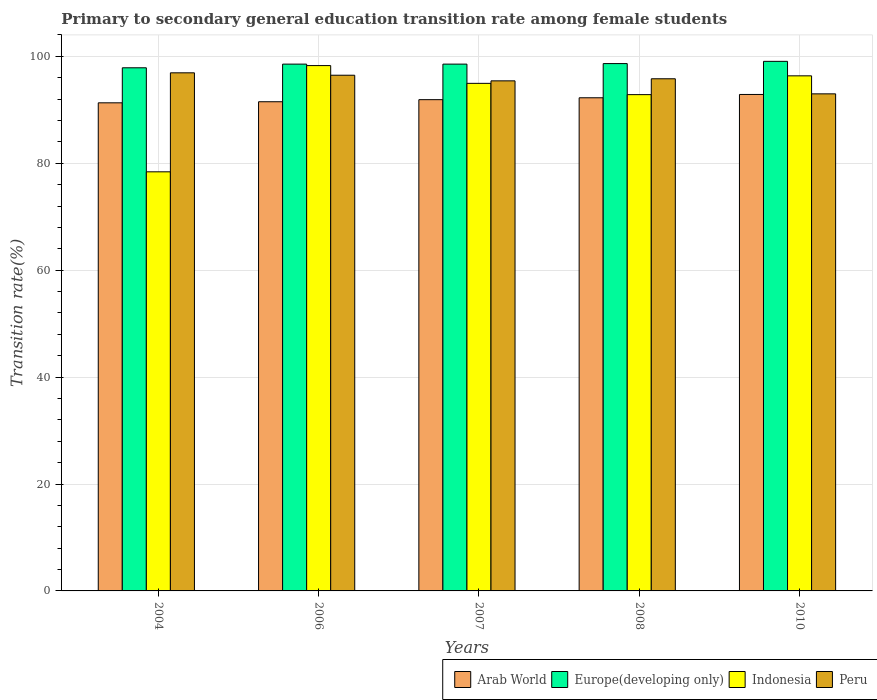How many different coloured bars are there?
Offer a terse response. 4. Are the number of bars per tick equal to the number of legend labels?
Keep it short and to the point. Yes. Are the number of bars on each tick of the X-axis equal?
Ensure brevity in your answer.  Yes. How many bars are there on the 2nd tick from the left?
Your answer should be very brief. 4. In how many cases, is the number of bars for a given year not equal to the number of legend labels?
Your response must be concise. 0. What is the transition rate in Europe(developing only) in 2010?
Your response must be concise. 99.07. Across all years, what is the maximum transition rate in Indonesia?
Your answer should be very brief. 98.28. Across all years, what is the minimum transition rate in Indonesia?
Make the answer very short. 78.4. In which year was the transition rate in Europe(developing only) minimum?
Make the answer very short. 2004. What is the total transition rate in Indonesia in the graph?
Give a very brief answer. 460.83. What is the difference between the transition rate in Peru in 2004 and that in 2006?
Make the answer very short. 0.45. What is the difference between the transition rate in Indonesia in 2010 and the transition rate in Europe(developing only) in 2004?
Your answer should be very brief. -1.5. What is the average transition rate in Arab World per year?
Your answer should be very brief. 91.97. In the year 2004, what is the difference between the transition rate in Europe(developing only) and transition rate in Peru?
Offer a very short reply. 0.94. In how many years, is the transition rate in Peru greater than 80 %?
Offer a very short reply. 5. What is the ratio of the transition rate in Arab World in 2004 to that in 2006?
Provide a short and direct response. 1. Is the transition rate in Europe(developing only) in 2007 less than that in 2010?
Offer a very short reply. Yes. What is the difference between the highest and the second highest transition rate in Arab World?
Provide a short and direct response. 0.62. What is the difference between the highest and the lowest transition rate in Europe(developing only)?
Offer a terse response. 1.2. Is it the case that in every year, the sum of the transition rate in Arab World and transition rate in Peru is greater than the sum of transition rate in Indonesia and transition rate in Europe(developing only)?
Your response must be concise. No. What does the 1st bar from the left in 2007 represents?
Your answer should be compact. Arab World. What does the 3rd bar from the right in 2006 represents?
Your answer should be compact. Europe(developing only). Is it the case that in every year, the sum of the transition rate in Indonesia and transition rate in Arab World is greater than the transition rate in Peru?
Make the answer very short. Yes. How many years are there in the graph?
Offer a terse response. 5. What is the difference between two consecutive major ticks on the Y-axis?
Keep it short and to the point. 20. Does the graph contain grids?
Offer a very short reply. Yes. How many legend labels are there?
Your answer should be very brief. 4. What is the title of the graph?
Provide a short and direct response. Primary to secondary general education transition rate among female students. What is the label or title of the X-axis?
Ensure brevity in your answer.  Years. What is the label or title of the Y-axis?
Offer a terse response. Transition rate(%). What is the Transition rate(%) in Arab World in 2004?
Offer a terse response. 91.31. What is the Transition rate(%) of Europe(developing only) in 2004?
Provide a short and direct response. 97.86. What is the Transition rate(%) in Indonesia in 2004?
Keep it short and to the point. 78.4. What is the Transition rate(%) of Peru in 2004?
Provide a short and direct response. 96.92. What is the Transition rate(%) in Arab World in 2006?
Your answer should be compact. 91.51. What is the Transition rate(%) in Europe(developing only) in 2006?
Offer a terse response. 98.55. What is the Transition rate(%) in Indonesia in 2006?
Make the answer very short. 98.28. What is the Transition rate(%) in Peru in 2006?
Provide a short and direct response. 96.47. What is the Transition rate(%) of Arab World in 2007?
Your response must be concise. 91.9. What is the Transition rate(%) of Europe(developing only) in 2007?
Give a very brief answer. 98.55. What is the Transition rate(%) of Indonesia in 2007?
Keep it short and to the point. 94.95. What is the Transition rate(%) in Peru in 2007?
Offer a very short reply. 95.42. What is the Transition rate(%) of Arab World in 2008?
Give a very brief answer. 92.25. What is the Transition rate(%) in Europe(developing only) in 2008?
Offer a very short reply. 98.65. What is the Transition rate(%) of Indonesia in 2008?
Provide a succinct answer. 92.84. What is the Transition rate(%) in Peru in 2008?
Keep it short and to the point. 95.81. What is the Transition rate(%) of Arab World in 2010?
Provide a short and direct response. 92.87. What is the Transition rate(%) in Europe(developing only) in 2010?
Your answer should be very brief. 99.07. What is the Transition rate(%) of Indonesia in 2010?
Your answer should be very brief. 96.36. What is the Transition rate(%) in Peru in 2010?
Offer a very short reply. 92.99. Across all years, what is the maximum Transition rate(%) in Arab World?
Your response must be concise. 92.87. Across all years, what is the maximum Transition rate(%) of Europe(developing only)?
Your answer should be compact. 99.07. Across all years, what is the maximum Transition rate(%) of Indonesia?
Ensure brevity in your answer.  98.28. Across all years, what is the maximum Transition rate(%) in Peru?
Ensure brevity in your answer.  96.92. Across all years, what is the minimum Transition rate(%) of Arab World?
Your answer should be very brief. 91.31. Across all years, what is the minimum Transition rate(%) of Europe(developing only)?
Your answer should be very brief. 97.86. Across all years, what is the minimum Transition rate(%) of Indonesia?
Give a very brief answer. 78.4. Across all years, what is the minimum Transition rate(%) of Peru?
Provide a succinct answer. 92.99. What is the total Transition rate(%) in Arab World in the graph?
Ensure brevity in your answer.  459.85. What is the total Transition rate(%) of Europe(developing only) in the graph?
Your answer should be compact. 492.68. What is the total Transition rate(%) in Indonesia in the graph?
Give a very brief answer. 460.83. What is the total Transition rate(%) in Peru in the graph?
Provide a short and direct response. 477.61. What is the difference between the Transition rate(%) in Arab World in 2004 and that in 2006?
Ensure brevity in your answer.  -0.2. What is the difference between the Transition rate(%) of Europe(developing only) in 2004 and that in 2006?
Your answer should be compact. -0.69. What is the difference between the Transition rate(%) in Indonesia in 2004 and that in 2006?
Offer a terse response. -19.87. What is the difference between the Transition rate(%) in Peru in 2004 and that in 2006?
Offer a very short reply. 0.45. What is the difference between the Transition rate(%) in Arab World in 2004 and that in 2007?
Your answer should be very brief. -0.59. What is the difference between the Transition rate(%) of Europe(developing only) in 2004 and that in 2007?
Your answer should be compact. -0.69. What is the difference between the Transition rate(%) of Indonesia in 2004 and that in 2007?
Your response must be concise. -16.55. What is the difference between the Transition rate(%) of Peru in 2004 and that in 2007?
Make the answer very short. 1.5. What is the difference between the Transition rate(%) of Arab World in 2004 and that in 2008?
Your answer should be very brief. -0.94. What is the difference between the Transition rate(%) of Europe(developing only) in 2004 and that in 2008?
Offer a terse response. -0.79. What is the difference between the Transition rate(%) of Indonesia in 2004 and that in 2008?
Give a very brief answer. -14.44. What is the difference between the Transition rate(%) in Peru in 2004 and that in 2008?
Provide a short and direct response. 1.11. What is the difference between the Transition rate(%) of Arab World in 2004 and that in 2010?
Keep it short and to the point. -1.56. What is the difference between the Transition rate(%) in Europe(developing only) in 2004 and that in 2010?
Offer a terse response. -1.2. What is the difference between the Transition rate(%) of Indonesia in 2004 and that in 2010?
Your response must be concise. -17.96. What is the difference between the Transition rate(%) in Peru in 2004 and that in 2010?
Provide a short and direct response. 3.93. What is the difference between the Transition rate(%) of Arab World in 2006 and that in 2007?
Your answer should be very brief. -0.39. What is the difference between the Transition rate(%) of Europe(developing only) in 2006 and that in 2007?
Your response must be concise. -0. What is the difference between the Transition rate(%) in Indonesia in 2006 and that in 2007?
Ensure brevity in your answer.  3.33. What is the difference between the Transition rate(%) of Peru in 2006 and that in 2007?
Provide a short and direct response. 1.05. What is the difference between the Transition rate(%) of Arab World in 2006 and that in 2008?
Offer a terse response. -0.74. What is the difference between the Transition rate(%) in Europe(developing only) in 2006 and that in 2008?
Give a very brief answer. -0.1. What is the difference between the Transition rate(%) in Indonesia in 2006 and that in 2008?
Provide a succinct answer. 5.43. What is the difference between the Transition rate(%) of Peru in 2006 and that in 2008?
Your answer should be very brief. 0.66. What is the difference between the Transition rate(%) of Arab World in 2006 and that in 2010?
Keep it short and to the point. -1.36. What is the difference between the Transition rate(%) in Europe(developing only) in 2006 and that in 2010?
Your answer should be very brief. -0.52. What is the difference between the Transition rate(%) in Indonesia in 2006 and that in 2010?
Ensure brevity in your answer.  1.92. What is the difference between the Transition rate(%) in Peru in 2006 and that in 2010?
Your answer should be compact. 3.48. What is the difference between the Transition rate(%) of Arab World in 2007 and that in 2008?
Make the answer very short. -0.35. What is the difference between the Transition rate(%) in Europe(developing only) in 2007 and that in 2008?
Provide a succinct answer. -0.1. What is the difference between the Transition rate(%) of Indonesia in 2007 and that in 2008?
Make the answer very short. 2.11. What is the difference between the Transition rate(%) of Peru in 2007 and that in 2008?
Keep it short and to the point. -0.39. What is the difference between the Transition rate(%) in Arab World in 2007 and that in 2010?
Your answer should be very brief. -0.97. What is the difference between the Transition rate(%) in Europe(developing only) in 2007 and that in 2010?
Make the answer very short. -0.52. What is the difference between the Transition rate(%) of Indonesia in 2007 and that in 2010?
Ensure brevity in your answer.  -1.41. What is the difference between the Transition rate(%) of Peru in 2007 and that in 2010?
Keep it short and to the point. 2.43. What is the difference between the Transition rate(%) in Arab World in 2008 and that in 2010?
Ensure brevity in your answer.  -0.62. What is the difference between the Transition rate(%) of Europe(developing only) in 2008 and that in 2010?
Keep it short and to the point. -0.42. What is the difference between the Transition rate(%) of Indonesia in 2008 and that in 2010?
Your answer should be very brief. -3.52. What is the difference between the Transition rate(%) in Peru in 2008 and that in 2010?
Make the answer very short. 2.82. What is the difference between the Transition rate(%) of Arab World in 2004 and the Transition rate(%) of Europe(developing only) in 2006?
Provide a short and direct response. -7.24. What is the difference between the Transition rate(%) in Arab World in 2004 and the Transition rate(%) in Indonesia in 2006?
Offer a terse response. -6.97. What is the difference between the Transition rate(%) of Arab World in 2004 and the Transition rate(%) of Peru in 2006?
Provide a short and direct response. -5.16. What is the difference between the Transition rate(%) in Europe(developing only) in 2004 and the Transition rate(%) in Indonesia in 2006?
Offer a terse response. -0.41. What is the difference between the Transition rate(%) of Europe(developing only) in 2004 and the Transition rate(%) of Peru in 2006?
Offer a very short reply. 1.39. What is the difference between the Transition rate(%) of Indonesia in 2004 and the Transition rate(%) of Peru in 2006?
Give a very brief answer. -18.07. What is the difference between the Transition rate(%) of Arab World in 2004 and the Transition rate(%) of Europe(developing only) in 2007?
Give a very brief answer. -7.24. What is the difference between the Transition rate(%) in Arab World in 2004 and the Transition rate(%) in Indonesia in 2007?
Your answer should be very brief. -3.64. What is the difference between the Transition rate(%) of Arab World in 2004 and the Transition rate(%) of Peru in 2007?
Give a very brief answer. -4.11. What is the difference between the Transition rate(%) of Europe(developing only) in 2004 and the Transition rate(%) of Indonesia in 2007?
Give a very brief answer. 2.91. What is the difference between the Transition rate(%) of Europe(developing only) in 2004 and the Transition rate(%) of Peru in 2007?
Your response must be concise. 2.44. What is the difference between the Transition rate(%) of Indonesia in 2004 and the Transition rate(%) of Peru in 2007?
Offer a very short reply. -17.02. What is the difference between the Transition rate(%) of Arab World in 2004 and the Transition rate(%) of Europe(developing only) in 2008?
Your answer should be compact. -7.34. What is the difference between the Transition rate(%) in Arab World in 2004 and the Transition rate(%) in Indonesia in 2008?
Make the answer very short. -1.53. What is the difference between the Transition rate(%) in Arab World in 2004 and the Transition rate(%) in Peru in 2008?
Your answer should be very brief. -4.5. What is the difference between the Transition rate(%) of Europe(developing only) in 2004 and the Transition rate(%) of Indonesia in 2008?
Your response must be concise. 5.02. What is the difference between the Transition rate(%) in Europe(developing only) in 2004 and the Transition rate(%) in Peru in 2008?
Offer a very short reply. 2.05. What is the difference between the Transition rate(%) in Indonesia in 2004 and the Transition rate(%) in Peru in 2008?
Provide a short and direct response. -17.41. What is the difference between the Transition rate(%) of Arab World in 2004 and the Transition rate(%) of Europe(developing only) in 2010?
Keep it short and to the point. -7.76. What is the difference between the Transition rate(%) of Arab World in 2004 and the Transition rate(%) of Indonesia in 2010?
Offer a terse response. -5.05. What is the difference between the Transition rate(%) of Arab World in 2004 and the Transition rate(%) of Peru in 2010?
Offer a very short reply. -1.68. What is the difference between the Transition rate(%) in Europe(developing only) in 2004 and the Transition rate(%) in Indonesia in 2010?
Keep it short and to the point. 1.5. What is the difference between the Transition rate(%) in Europe(developing only) in 2004 and the Transition rate(%) in Peru in 2010?
Provide a succinct answer. 4.87. What is the difference between the Transition rate(%) in Indonesia in 2004 and the Transition rate(%) in Peru in 2010?
Offer a terse response. -14.59. What is the difference between the Transition rate(%) of Arab World in 2006 and the Transition rate(%) of Europe(developing only) in 2007?
Offer a terse response. -7.04. What is the difference between the Transition rate(%) of Arab World in 2006 and the Transition rate(%) of Indonesia in 2007?
Ensure brevity in your answer.  -3.44. What is the difference between the Transition rate(%) in Arab World in 2006 and the Transition rate(%) in Peru in 2007?
Your answer should be compact. -3.91. What is the difference between the Transition rate(%) of Europe(developing only) in 2006 and the Transition rate(%) of Indonesia in 2007?
Make the answer very short. 3.6. What is the difference between the Transition rate(%) in Europe(developing only) in 2006 and the Transition rate(%) in Peru in 2007?
Your response must be concise. 3.13. What is the difference between the Transition rate(%) of Indonesia in 2006 and the Transition rate(%) of Peru in 2007?
Your answer should be compact. 2.86. What is the difference between the Transition rate(%) of Arab World in 2006 and the Transition rate(%) of Europe(developing only) in 2008?
Ensure brevity in your answer.  -7.14. What is the difference between the Transition rate(%) in Arab World in 2006 and the Transition rate(%) in Indonesia in 2008?
Keep it short and to the point. -1.33. What is the difference between the Transition rate(%) in Arab World in 2006 and the Transition rate(%) in Peru in 2008?
Your answer should be very brief. -4.3. What is the difference between the Transition rate(%) of Europe(developing only) in 2006 and the Transition rate(%) of Indonesia in 2008?
Keep it short and to the point. 5.71. What is the difference between the Transition rate(%) in Europe(developing only) in 2006 and the Transition rate(%) in Peru in 2008?
Provide a short and direct response. 2.74. What is the difference between the Transition rate(%) of Indonesia in 2006 and the Transition rate(%) of Peru in 2008?
Your answer should be very brief. 2.47. What is the difference between the Transition rate(%) in Arab World in 2006 and the Transition rate(%) in Europe(developing only) in 2010?
Provide a short and direct response. -7.56. What is the difference between the Transition rate(%) in Arab World in 2006 and the Transition rate(%) in Indonesia in 2010?
Give a very brief answer. -4.85. What is the difference between the Transition rate(%) in Arab World in 2006 and the Transition rate(%) in Peru in 2010?
Your response must be concise. -1.48. What is the difference between the Transition rate(%) in Europe(developing only) in 2006 and the Transition rate(%) in Indonesia in 2010?
Offer a terse response. 2.19. What is the difference between the Transition rate(%) in Europe(developing only) in 2006 and the Transition rate(%) in Peru in 2010?
Your answer should be very brief. 5.56. What is the difference between the Transition rate(%) in Indonesia in 2006 and the Transition rate(%) in Peru in 2010?
Your response must be concise. 5.29. What is the difference between the Transition rate(%) of Arab World in 2007 and the Transition rate(%) of Europe(developing only) in 2008?
Give a very brief answer. -6.75. What is the difference between the Transition rate(%) of Arab World in 2007 and the Transition rate(%) of Indonesia in 2008?
Make the answer very short. -0.94. What is the difference between the Transition rate(%) of Arab World in 2007 and the Transition rate(%) of Peru in 2008?
Keep it short and to the point. -3.91. What is the difference between the Transition rate(%) in Europe(developing only) in 2007 and the Transition rate(%) in Indonesia in 2008?
Give a very brief answer. 5.71. What is the difference between the Transition rate(%) in Europe(developing only) in 2007 and the Transition rate(%) in Peru in 2008?
Your answer should be very brief. 2.74. What is the difference between the Transition rate(%) in Indonesia in 2007 and the Transition rate(%) in Peru in 2008?
Ensure brevity in your answer.  -0.86. What is the difference between the Transition rate(%) of Arab World in 2007 and the Transition rate(%) of Europe(developing only) in 2010?
Offer a terse response. -7.17. What is the difference between the Transition rate(%) in Arab World in 2007 and the Transition rate(%) in Indonesia in 2010?
Your answer should be very brief. -4.46. What is the difference between the Transition rate(%) in Arab World in 2007 and the Transition rate(%) in Peru in 2010?
Ensure brevity in your answer.  -1.09. What is the difference between the Transition rate(%) in Europe(developing only) in 2007 and the Transition rate(%) in Indonesia in 2010?
Make the answer very short. 2.19. What is the difference between the Transition rate(%) in Europe(developing only) in 2007 and the Transition rate(%) in Peru in 2010?
Offer a very short reply. 5.56. What is the difference between the Transition rate(%) of Indonesia in 2007 and the Transition rate(%) of Peru in 2010?
Provide a short and direct response. 1.96. What is the difference between the Transition rate(%) in Arab World in 2008 and the Transition rate(%) in Europe(developing only) in 2010?
Provide a short and direct response. -6.81. What is the difference between the Transition rate(%) in Arab World in 2008 and the Transition rate(%) in Indonesia in 2010?
Offer a very short reply. -4.11. What is the difference between the Transition rate(%) in Arab World in 2008 and the Transition rate(%) in Peru in 2010?
Your response must be concise. -0.74. What is the difference between the Transition rate(%) in Europe(developing only) in 2008 and the Transition rate(%) in Indonesia in 2010?
Keep it short and to the point. 2.29. What is the difference between the Transition rate(%) in Europe(developing only) in 2008 and the Transition rate(%) in Peru in 2010?
Offer a very short reply. 5.66. What is the difference between the Transition rate(%) in Indonesia in 2008 and the Transition rate(%) in Peru in 2010?
Offer a terse response. -0.15. What is the average Transition rate(%) in Arab World per year?
Ensure brevity in your answer.  91.97. What is the average Transition rate(%) of Europe(developing only) per year?
Keep it short and to the point. 98.54. What is the average Transition rate(%) of Indonesia per year?
Provide a succinct answer. 92.17. What is the average Transition rate(%) in Peru per year?
Ensure brevity in your answer.  95.52. In the year 2004, what is the difference between the Transition rate(%) in Arab World and Transition rate(%) in Europe(developing only)?
Make the answer very short. -6.55. In the year 2004, what is the difference between the Transition rate(%) in Arab World and Transition rate(%) in Indonesia?
Ensure brevity in your answer.  12.91. In the year 2004, what is the difference between the Transition rate(%) of Arab World and Transition rate(%) of Peru?
Offer a terse response. -5.61. In the year 2004, what is the difference between the Transition rate(%) of Europe(developing only) and Transition rate(%) of Indonesia?
Offer a terse response. 19.46. In the year 2004, what is the difference between the Transition rate(%) of Europe(developing only) and Transition rate(%) of Peru?
Give a very brief answer. 0.94. In the year 2004, what is the difference between the Transition rate(%) of Indonesia and Transition rate(%) of Peru?
Provide a short and direct response. -18.52. In the year 2006, what is the difference between the Transition rate(%) in Arab World and Transition rate(%) in Europe(developing only)?
Ensure brevity in your answer.  -7.04. In the year 2006, what is the difference between the Transition rate(%) in Arab World and Transition rate(%) in Indonesia?
Your answer should be compact. -6.77. In the year 2006, what is the difference between the Transition rate(%) in Arab World and Transition rate(%) in Peru?
Your response must be concise. -4.96. In the year 2006, what is the difference between the Transition rate(%) of Europe(developing only) and Transition rate(%) of Indonesia?
Offer a very short reply. 0.27. In the year 2006, what is the difference between the Transition rate(%) in Europe(developing only) and Transition rate(%) in Peru?
Ensure brevity in your answer.  2.08. In the year 2006, what is the difference between the Transition rate(%) of Indonesia and Transition rate(%) of Peru?
Your response must be concise. 1.8. In the year 2007, what is the difference between the Transition rate(%) in Arab World and Transition rate(%) in Europe(developing only)?
Your answer should be very brief. -6.65. In the year 2007, what is the difference between the Transition rate(%) in Arab World and Transition rate(%) in Indonesia?
Offer a terse response. -3.05. In the year 2007, what is the difference between the Transition rate(%) in Arab World and Transition rate(%) in Peru?
Offer a very short reply. -3.52. In the year 2007, what is the difference between the Transition rate(%) in Europe(developing only) and Transition rate(%) in Indonesia?
Give a very brief answer. 3.6. In the year 2007, what is the difference between the Transition rate(%) of Europe(developing only) and Transition rate(%) of Peru?
Give a very brief answer. 3.13. In the year 2007, what is the difference between the Transition rate(%) in Indonesia and Transition rate(%) in Peru?
Keep it short and to the point. -0.47. In the year 2008, what is the difference between the Transition rate(%) in Arab World and Transition rate(%) in Europe(developing only)?
Your response must be concise. -6.4. In the year 2008, what is the difference between the Transition rate(%) of Arab World and Transition rate(%) of Indonesia?
Give a very brief answer. -0.59. In the year 2008, what is the difference between the Transition rate(%) of Arab World and Transition rate(%) of Peru?
Provide a short and direct response. -3.56. In the year 2008, what is the difference between the Transition rate(%) in Europe(developing only) and Transition rate(%) in Indonesia?
Your answer should be very brief. 5.81. In the year 2008, what is the difference between the Transition rate(%) of Europe(developing only) and Transition rate(%) of Peru?
Your answer should be compact. 2.84. In the year 2008, what is the difference between the Transition rate(%) in Indonesia and Transition rate(%) in Peru?
Make the answer very short. -2.97. In the year 2010, what is the difference between the Transition rate(%) of Arab World and Transition rate(%) of Europe(developing only)?
Your response must be concise. -6.19. In the year 2010, what is the difference between the Transition rate(%) of Arab World and Transition rate(%) of Indonesia?
Make the answer very short. -3.48. In the year 2010, what is the difference between the Transition rate(%) of Arab World and Transition rate(%) of Peru?
Your answer should be very brief. -0.11. In the year 2010, what is the difference between the Transition rate(%) of Europe(developing only) and Transition rate(%) of Indonesia?
Your answer should be compact. 2.71. In the year 2010, what is the difference between the Transition rate(%) of Europe(developing only) and Transition rate(%) of Peru?
Your answer should be compact. 6.08. In the year 2010, what is the difference between the Transition rate(%) in Indonesia and Transition rate(%) in Peru?
Keep it short and to the point. 3.37. What is the ratio of the Transition rate(%) in Arab World in 2004 to that in 2006?
Your answer should be compact. 1. What is the ratio of the Transition rate(%) of Indonesia in 2004 to that in 2006?
Offer a terse response. 0.8. What is the ratio of the Transition rate(%) in Europe(developing only) in 2004 to that in 2007?
Your answer should be compact. 0.99. What is the ratio of the Transition rate(%) of Indonesia in 2004 to that in 2007?
Keep it short and to the point. 0.83. What is the ratio of the Transition rate(%) in Peru in 2004 to that in 2007?
Give a very brief answer. 1.02. What is the ratio of the Transition rate(%) in Indonesia in 2004 to that in 2008?
Your answer should be very brief. 0.84. What is the ratio of the Transition rate(%) in Peru in 2004 to that in 2008?
Keep it short and to the point. 1.01. What is the ratio of the Transition rate(%) in Arab World in 2004 to that in 2010?
Your answer should be very brief. 0.98. What is the ratio of the Transition rate(%) of Europe(developing only) in 2004 to that in 2010?
Provide a short and direct response. 0.99. What is the ratio of the Transition rate(%) of Indonesia in 2004 to that in 2010?
Offer a terse response. 0.81. What is the ratio of the Transition rate(%) of Peru in 2004 to that in 2010?
Provide a succinct answer. 1.04. What is the ratio of the Transition rate(%) in Europe(developing only) in 2006 to that in 2007?
Your answer should be compact. 1. What is the ratio of the Transition rate(%) in Indonesia in 2006 to that in 2007?
Provide a short and direct response. 1.03. What is the ratio of the Transition rate(%) of Europe(developing only) in 2006 to that in 2008?
Your answer should be compact. 1. What is the ratio of the Transition rate(%) in Indonesia in 2006 to that in 2008?
Make the answer very short. 1.06. What is the ratio of the Transition rate(%) in Arab World in 2006 to that in 2010?
Provide a short and direct response. 0.99. What is the ratio of the Transition rate(%) in Indonesia in 2006 to that in 2010?
Keep it short and to the point. 1.02. What is the ratio of the Transition rate(%) in Peru in 2006 to that in 2010?
Provide a succinct answer. 1.04. What is the ratio of the Transition rate(%) of Arab World in 2007 to that in 2008?
Your answer should be very brief. 1. What is the ratio of the Transition rate(%) in Europe(developing only) in 2007 to that in 2008?
Your answer should be compact. 1. What is the ratio of the Transition rate(%) of Indonesia in 2007 to that in 2008?
Offer a very short reply. 1.02. What is the ratio of the Transition rate(%) in Europe(developing only) in 2007 to that in 2010?
Your answer should be compact. 0.99. What is the ratio of the Transition rate(%) of Indonesia in 2007 to that in 2010?
Ensure brevity in your answer.  0.99. What is the ratio of the Transition rate(%) of Peru in 2007 to that in 2010?
Give a very brief answer. 1.03. What is the ratio of the Transition rate(%) in Europe(developing only) in 2008 to that in 2010?
Offer a terse response. 1. What is the ratio of the Transition rate(%) in Indonesia in 2008 to that in 2010?
Provide a short and direct response. 0.96. What is the ratio of the Transition rate(%) in Peru in 2008 to that in 2010?
Your answer should be very brief. 1.03. What is the difference between the highest and the second highest Transition rate(%) in Arab World?
Make the answer very short. 0.62. What is the difference between the highest and the second highest Transition rate(%) of Europe(developing only)?
Provide a short and direct response. 0.42. What is the difference between the highest and the second highest Transition rate(%) in Indonesia?
Offer a very short reply. 1.92. What is the difference between the highest and the second highest Transition rate(%) in Peru?
Offer a terse response. 0.45. What is the difference between the highest and the lowest Transition rate(%) of Arab World?
Give a very brief answer. 1.56. What is the difference between the highest and the lowest Transition rate(%) in Europe(developing only)?
Make the answer very short. 1.2. What is the difference between the highest and the lowest Transition rate(%) of Indonesia?
Keep it short and to the point. 19.87. What is the difference between the highest and the lowest Transition rate(%) in Peru?
Make the answer very short. 3.93. 